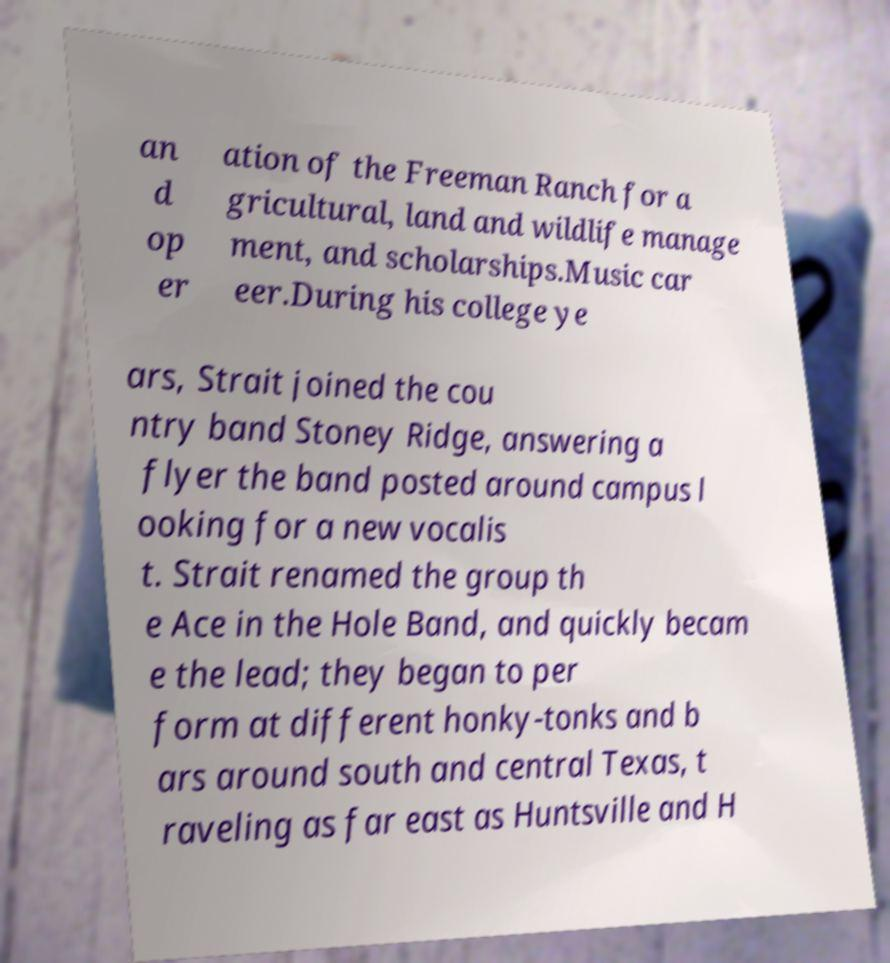Can you accurately transcribe the text from the provided image for me? an d op er ation of the Freeman Ranch for a gricultural, land and wildlife manage ment, and scholarships.Music car eer.During his college ye ars, Strait joined the cou ntry band Stoney Ridge, answering a flyer the band posted around campus l ooking for a new vocalis t. Strait renamed the group th e Ace in the Hole Band, and quickly becam e the lead; they began to per form at different honky-tonks and b ars around south and central Texas, t raveling as far east as Huntsville and H 